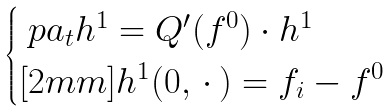<formula> <loc_0><loc_0><loc_500><loc_500>\begin{cases} \ p a _ { t } h ^ { 1 } = Q ^ { \prime } ( f ^ { 0 } ) \cdot h ^ { 1 } \\ [ 2 m m ] h ^ { 1 } ( 0 , \, \cdot \, ) = f _ { i } - f ^ { 0 } \end{cases}</formula> 